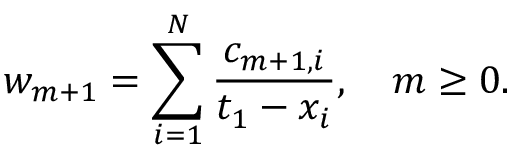Convert formula to latex. <formula><loc_0><loc_0><loc_500><loc_500>w _ { m + 1 } = \sum _ { i = 1 } ^ { N } { \frac { c _ { m + 1 , i } } { t _ { 1 } - x _ { i } } } , \quad m \geq 0 .</formula> 